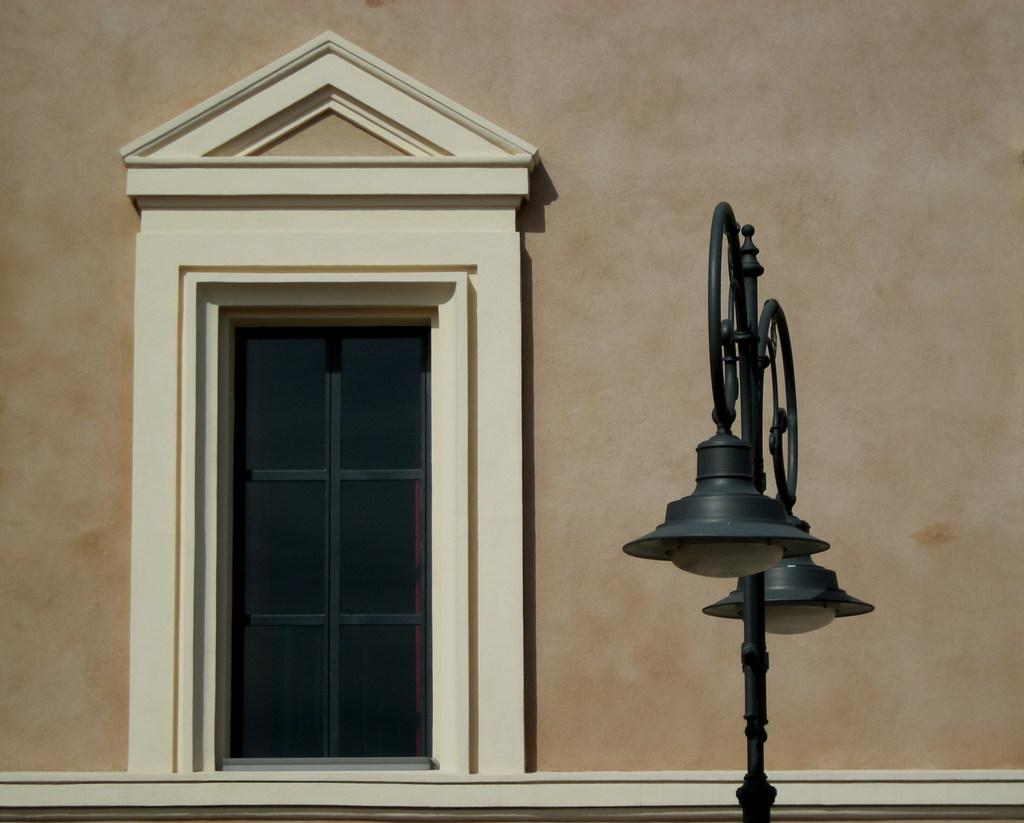What is located in the middle of the image? There is a window in the middle of the image. What can be seen on the right side of the image? There are two lamps on the right side of the image. What is above the window in the image? There is a wall above the window in the image. How many maids are visible in the image? There are no maids present in the image. Can you describe the kiss between the two people in the image? There are no people or kisses depicted in the image; it only features a window, two lamps, and a wall. 